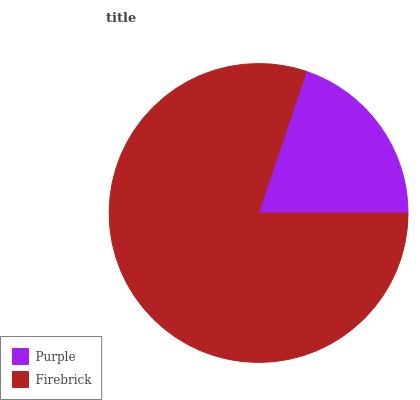Is Purple the minimum?
Answer yes or no. Yes. Is Firebrick the maximum?
Answer yes or no. Yes. Is Firebrick the minimum?
Answer yes or no. No. Is Firebrick greater than Purple?
Answer yes or no. Yes. Is Purple less than Firebrick?
Answer yes or no. Yes. Is Purple greater than Firebrick?
Answer yes or no. No. Is Firebrick less than Purple?
Answer yes or no. No. Is Firebrick the high median?
Answer yes or no. Yes. Is Purple the low median?
Answer yes or no. Yes. Is Purple the high median?
Answer yes or no. No. Is Firebrick the low median?
Answer yes or no. No. 